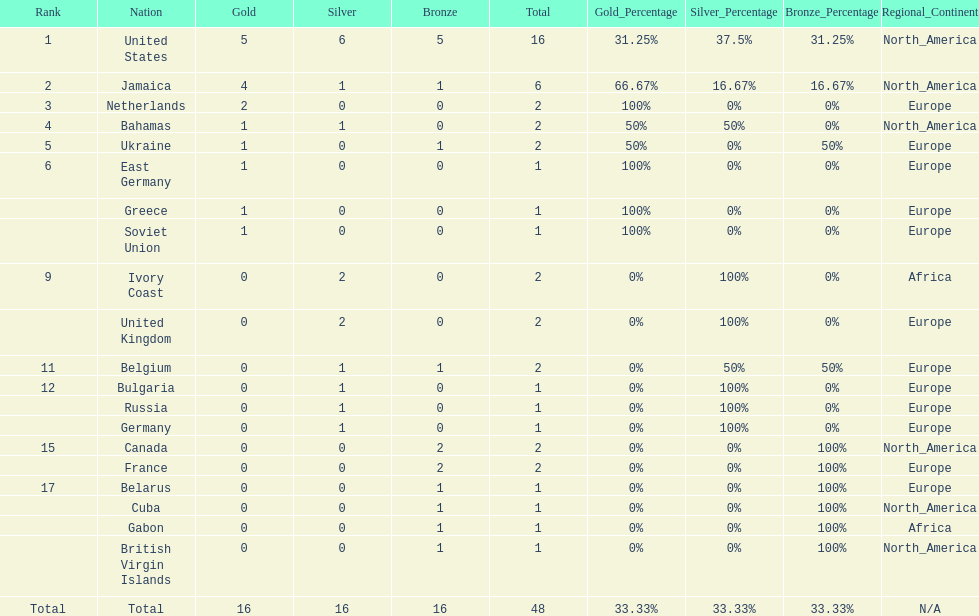How many nations won no gold medals? 12. 